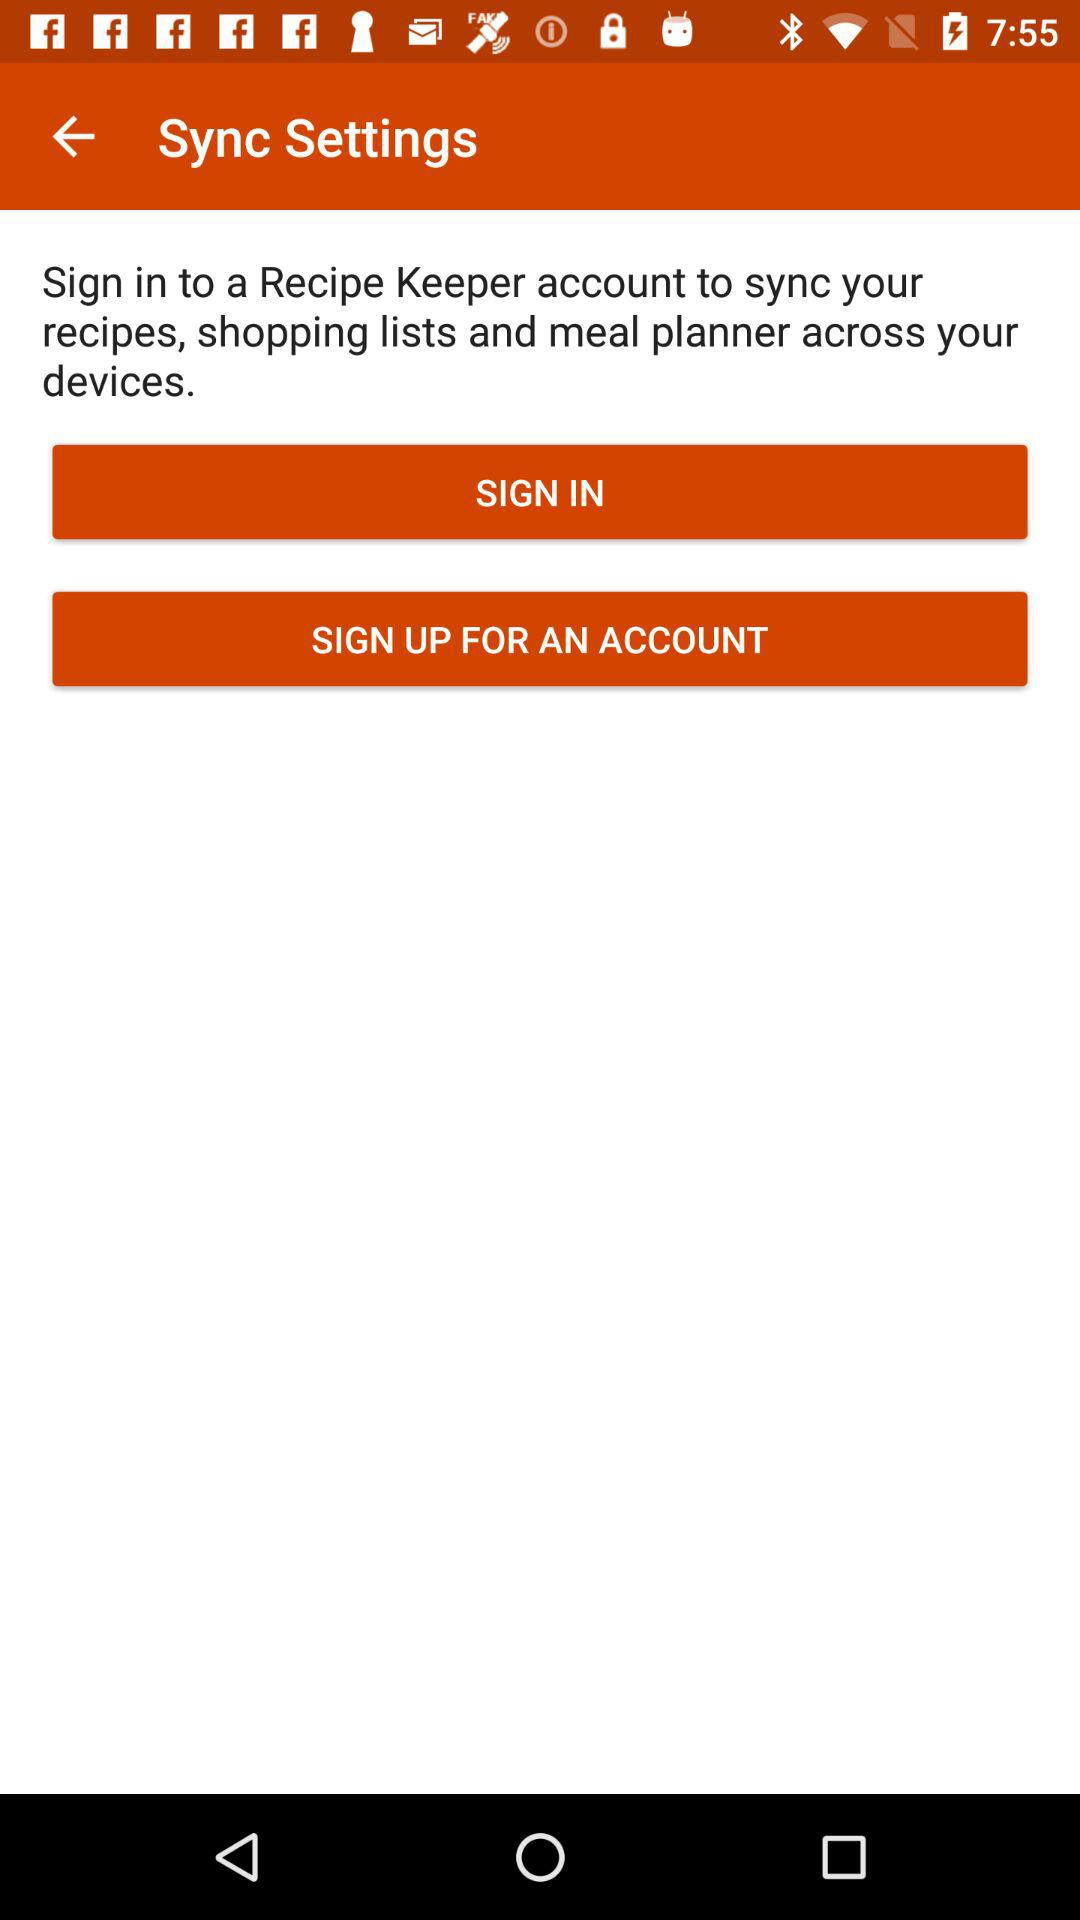What is the application name? The application name is "Recipe Keeper". 